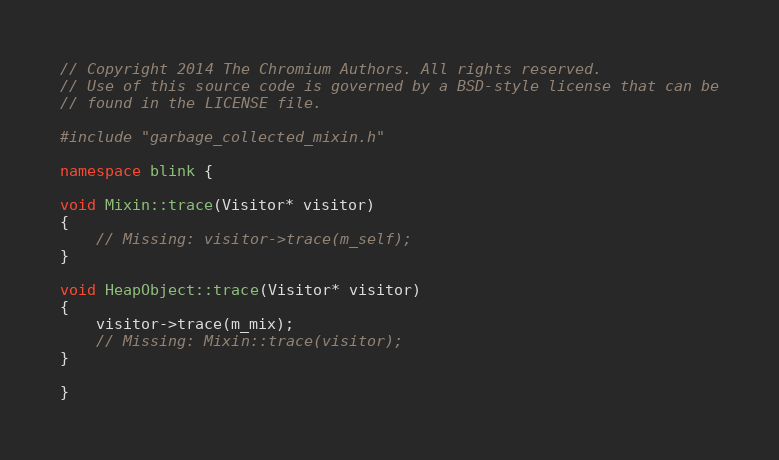<code> <loc_0><loc_0><loc_500><loc_500><_C++_>// Copyright 2014 The Chromium Authors. All rights reserved.
// Use of this source code is governed by a BSD-style license that can be
// found in the LICENSE file.

#include "garbage_collected_mixin.h"

namespace blink {

void Mixin::trace(Visitor* visitor)
{
    // Missing: visitor->trace(m_self);
}

void HeapObject::trace(Visitor* visitor)
{
    visitor->trace(m_mix);
    // Missing: Mixin::trace(visitor);
}

}
</code> 